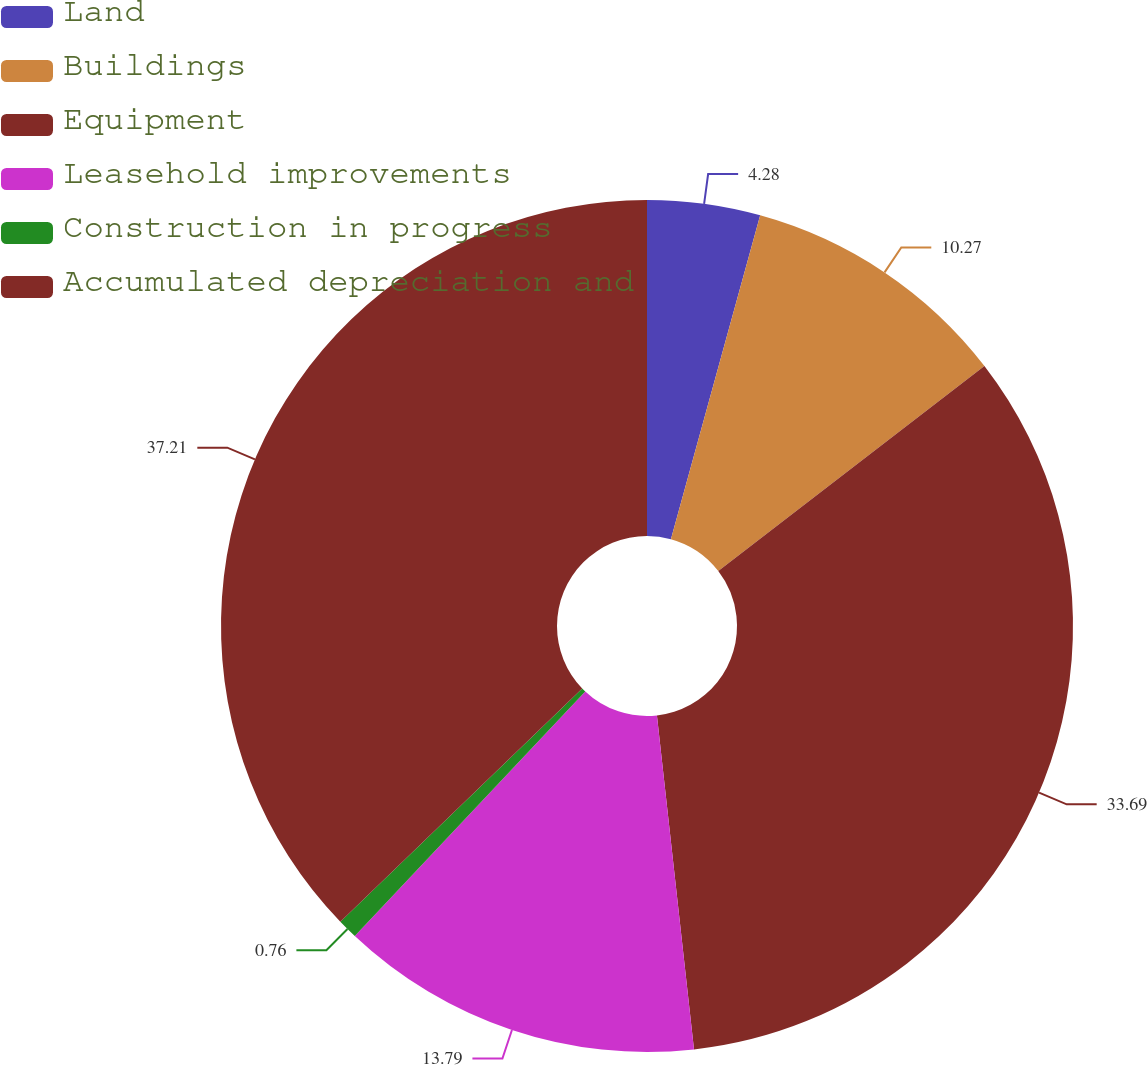Convert chart. <chart><loc_0><loc_0><loc_500><loc_500><pie_chart><fcel>Land<fcel>Buildings<fcel>Equipment<fcel>Leasehold improvements<fcel>Construction in progress<fcel>Accumulated depreciation and<nl><fcel>4.28%<fcel>10.27%<fcel>33.69%<fcel>13.79%<fcel>0.76%<fcel>37.21%<nl></chart> 